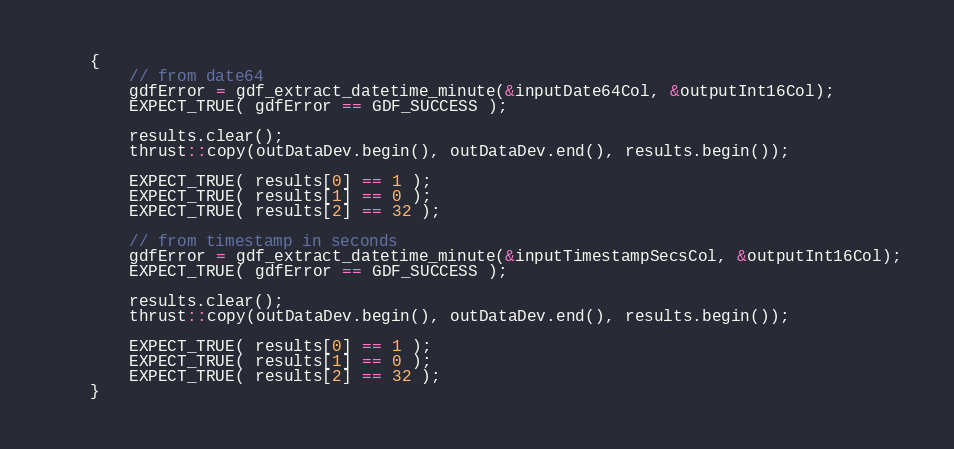<code> <loc_0><loc_0><loc_500><loc_500><_Cuda_>	{
		// from date64
		gdfError = gdf_extract_datetime_minute(&inputDate64Col, &outputInt16Col);
		EXPECT_TRUE( gdfError == GDF_SUCCESS );

		results.clear();
		thrust::copy(outDataDev.begin(), outDataDev.end(), results.begin());

		EXPECT_TRUE( results[0] == 1 );
		EXPECT_TRUE( results[1] == 0 );
		EXPECT_TRUE( results[2] == 32 );

		// from timestamp in seconds
		gdfError = gdf_extract_datetime_minute(&inputTimestampSecsCol, &outputInt16Col);
		EXPECT_TRUE( gdfError == GDF_SUCCESS );

		results.clear();
		thrust::copy(outDataDev.begin(), outDataDev.end(), results.begin());

		EXPECT_TRUE( results[0] == 1 );
		EXPECT_TRUE( results[1] == 0 );
		EXPECT_TRUE( results[2] == 32 );
	}
</code> 